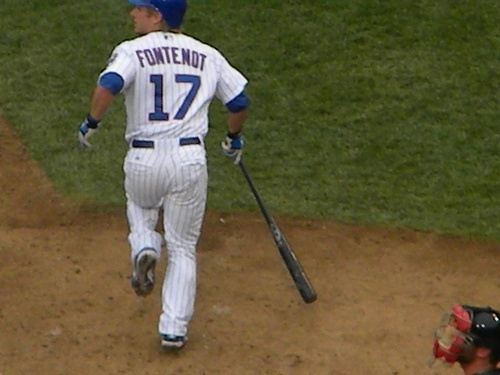Describe the objects in this image and their specific colors. I can see people in darkgreen, lavender, darkgray, and gray tones, people in darkgreen, black, maroon, and brown tones, and baseball bat in darkgreen, black, and gray tones in this image. 